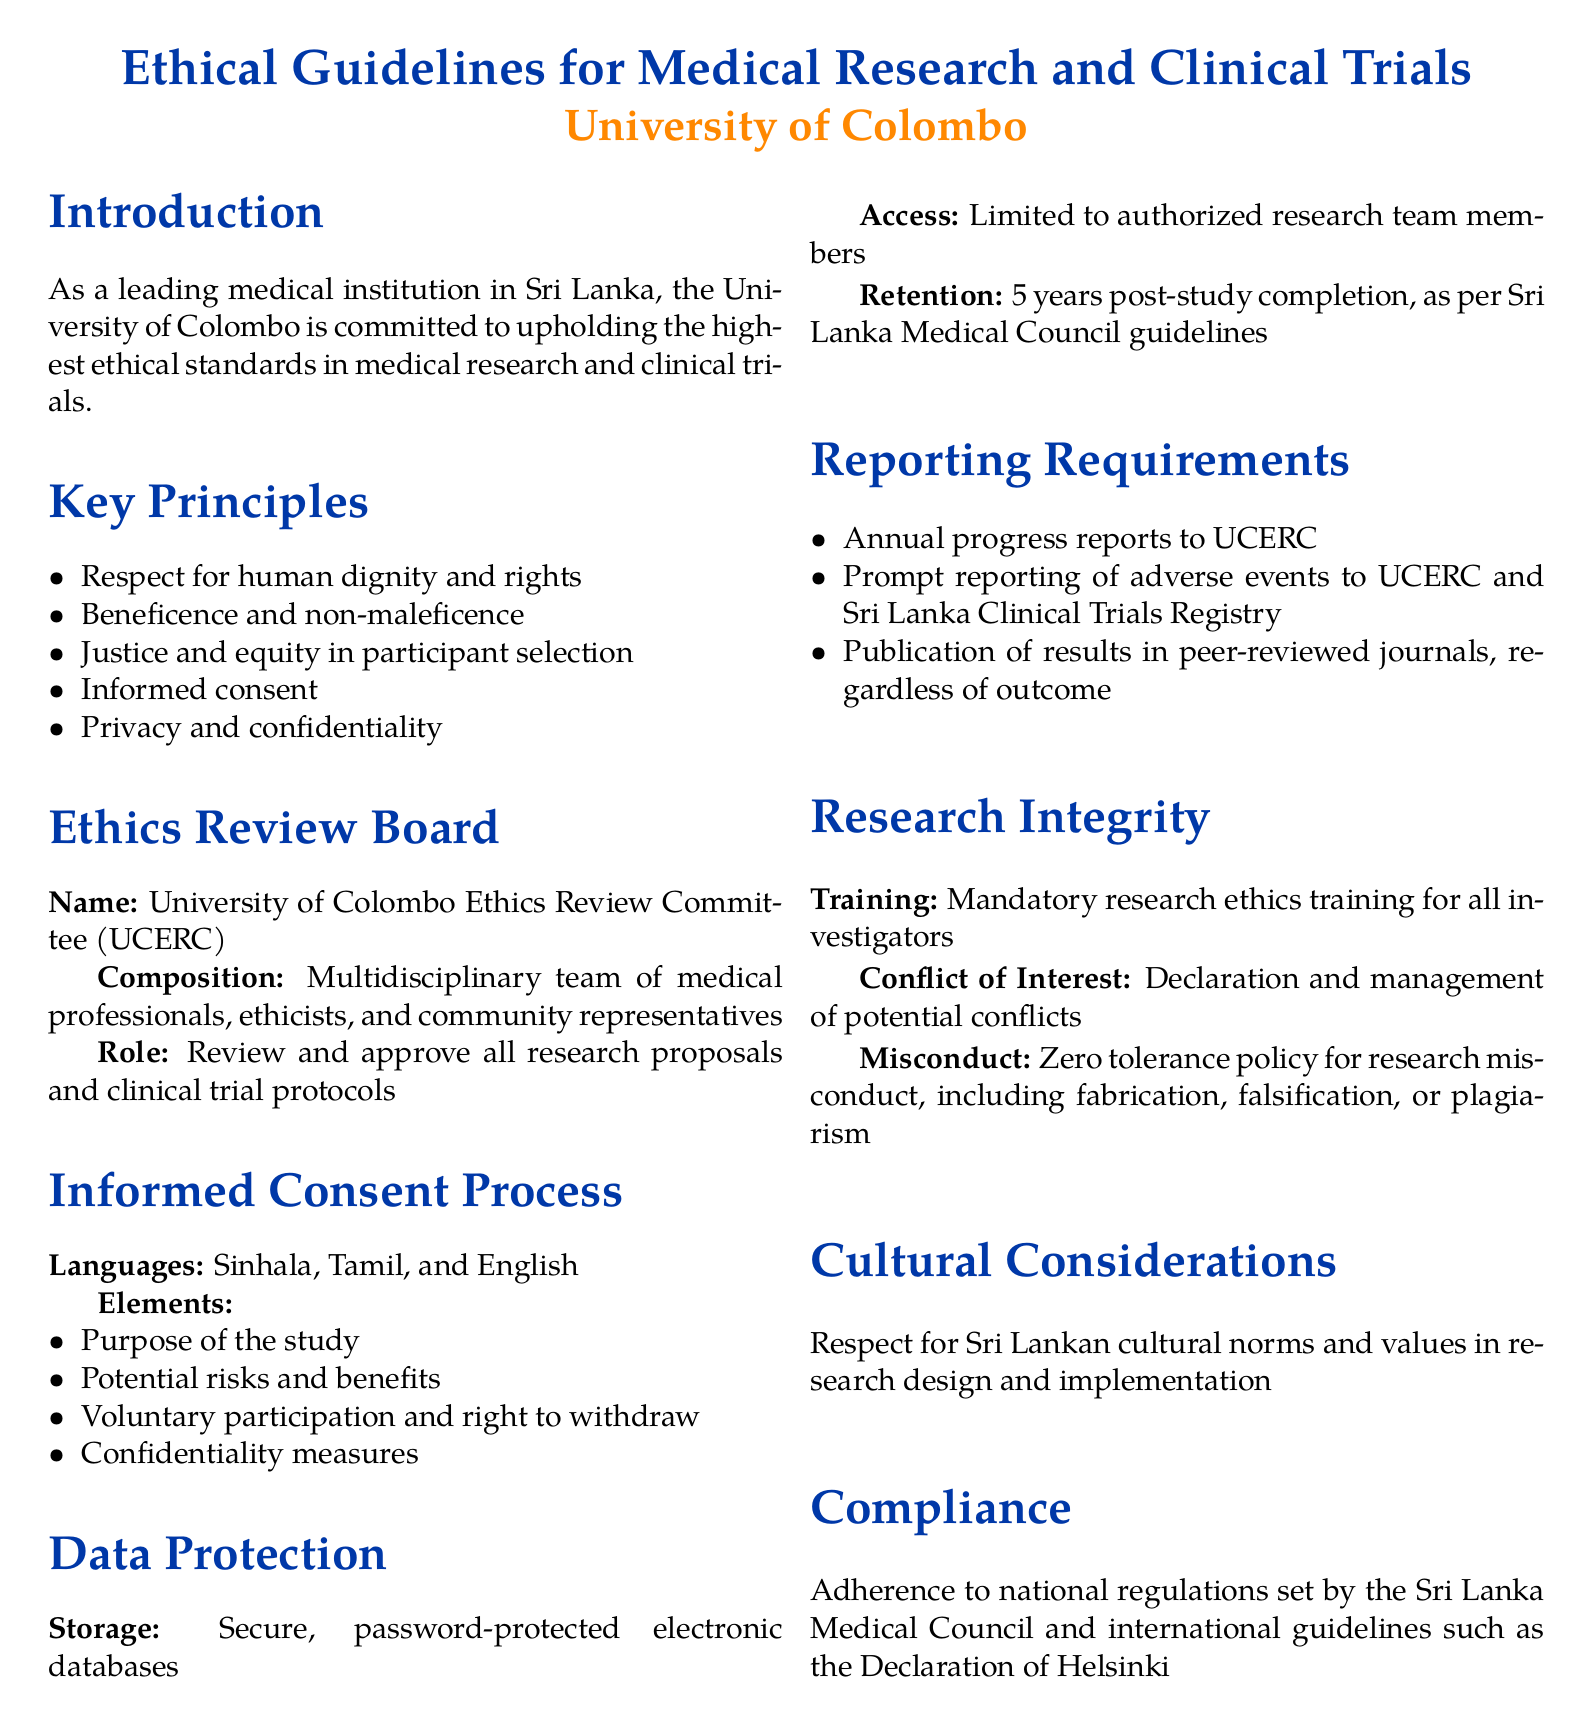What is the name of the ethics review board? The document explicitly states the name of the ethics review board as University of Colombo Ethics Review Committee (UCERC).
Answer: University of Colombo Ethics Review Committee (UCERC) What is the primary responsibility of the UCERC? The role of the UCERC is detailed in the document as reviewing and approving all research proposals and clinical trial protocols.
Answer: Review and approve all research proposals and clinical trial protocols How many languages are used in the informed consent process? The document lists three languages mentioned for the informed consent process, which include Sinhala, Tamil, and English.
Answer: Three What is the required retention period for data post-study completion? The document clearly states that the retention period for data is 5 years post-study completion.
Answer: 5 years What kind of training is mandated for investigators? The document mentions that there is mandatory research ethics training for all investigators, highlighting the importance of ethics in research.
Answer: Mandatory research ethics training What constitutes zero tolerance policy in research according to the document? The document explicitly mentions that zero tolerance policy applies to research misconduct, including fabrication, falsification, or plagiarism.
Answer: Research misconduct Which international guidelines should be adhered to as per the compliance section? The compliance section references the Declaration of Helsinki as one of the international guidelines to be adhered to.
Answer: Declaration of Helsinki What consideration is emphasized regarding Sri Lankan cultural norms? The document stresses respect for Sri Lankan cultural norms and values in research design and implementation.
Answer: Respect for Sri Lankan cultural norms What are the required reporting actions after an adverse event? The document specifies that there must be prompt reporting of adverse events to both UCERC and the Sri Lanka Clinical Trials Registry.
Answer: Prompt reporting to UCERC and Sri Lanka Clinical Trials Registry 